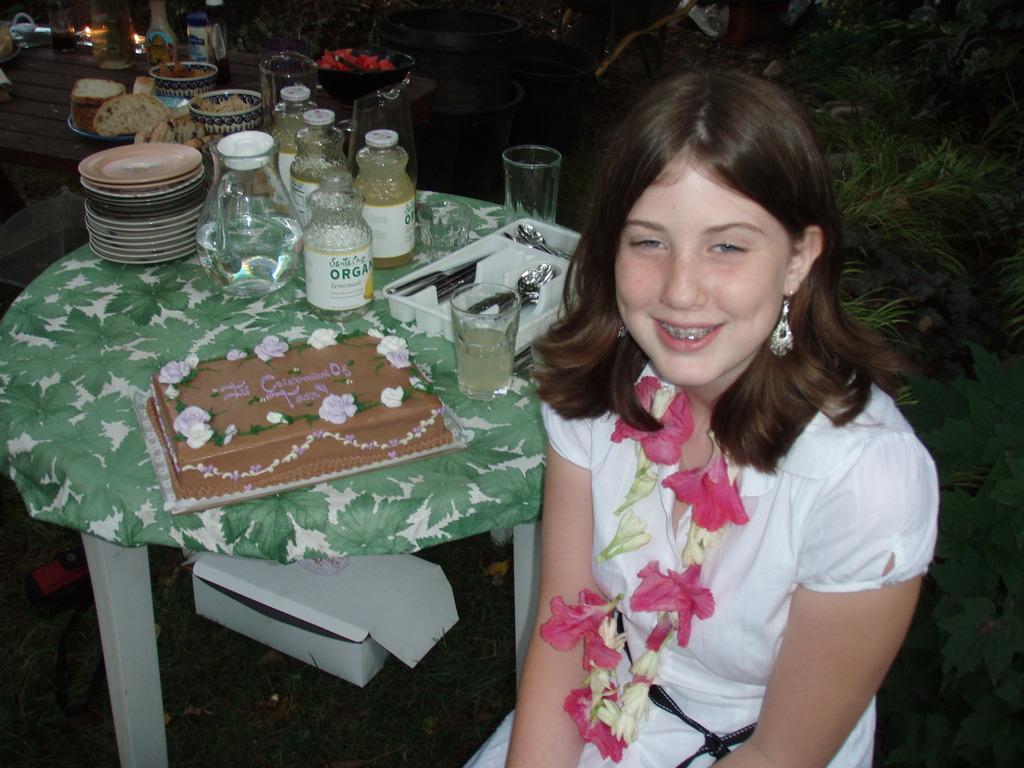Can you describe this image briefly? In this picture there is a girl smiling, beside her there is a table with a water jar, spoons, plates and water glasses and a cake. 